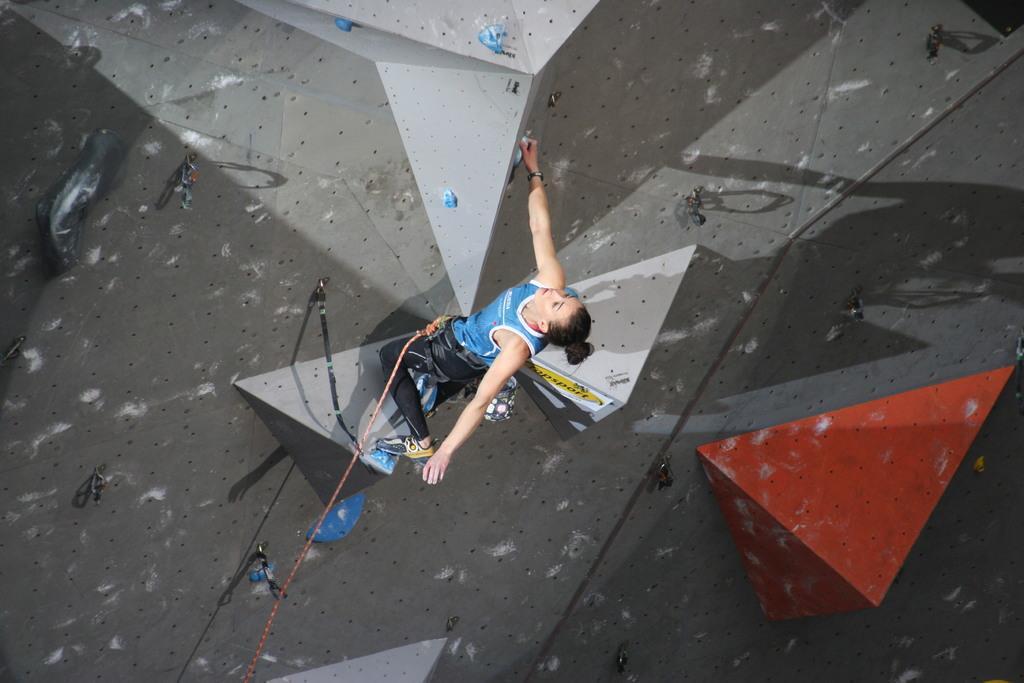How would you summarize this image in a sentence or two? In this image I can see the person wearing the blue and black color dress. I can see the person with the rope and belt. In-front of the person I can see the climbing wall. I can see some holders to the wall. 